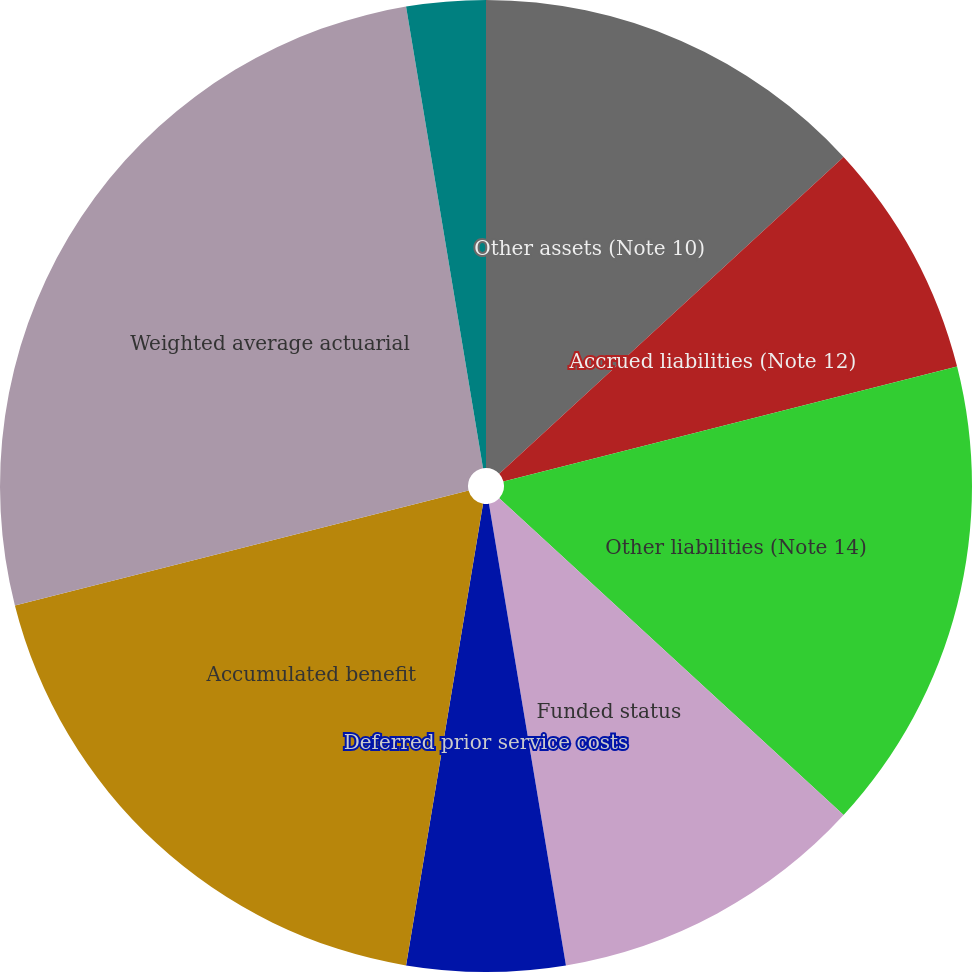Convert chart. <chart><loc_0><loc_0><loc_500><loc_500><pie_chart><fcel>Other assets (Note 10)<fcel>Accrued liabilities (Note 12)<fcel>Other liabilities (Note 14)<fcel>Funded status<fcel>Deferred prior service costs<fcel>Accumulated benefit<fcel>Weighted average actuarial<fcel>Discount rate<fcel>Rate of compensation increase<nl><fcel>13.16%<fcel>7.89%<fcel>15.79%<fcel>10.53%<fcel>5.26%<fcel>18.42%<fcel>26.32%<fcel>2.63%<fcel>0.0%<nl></chart> 